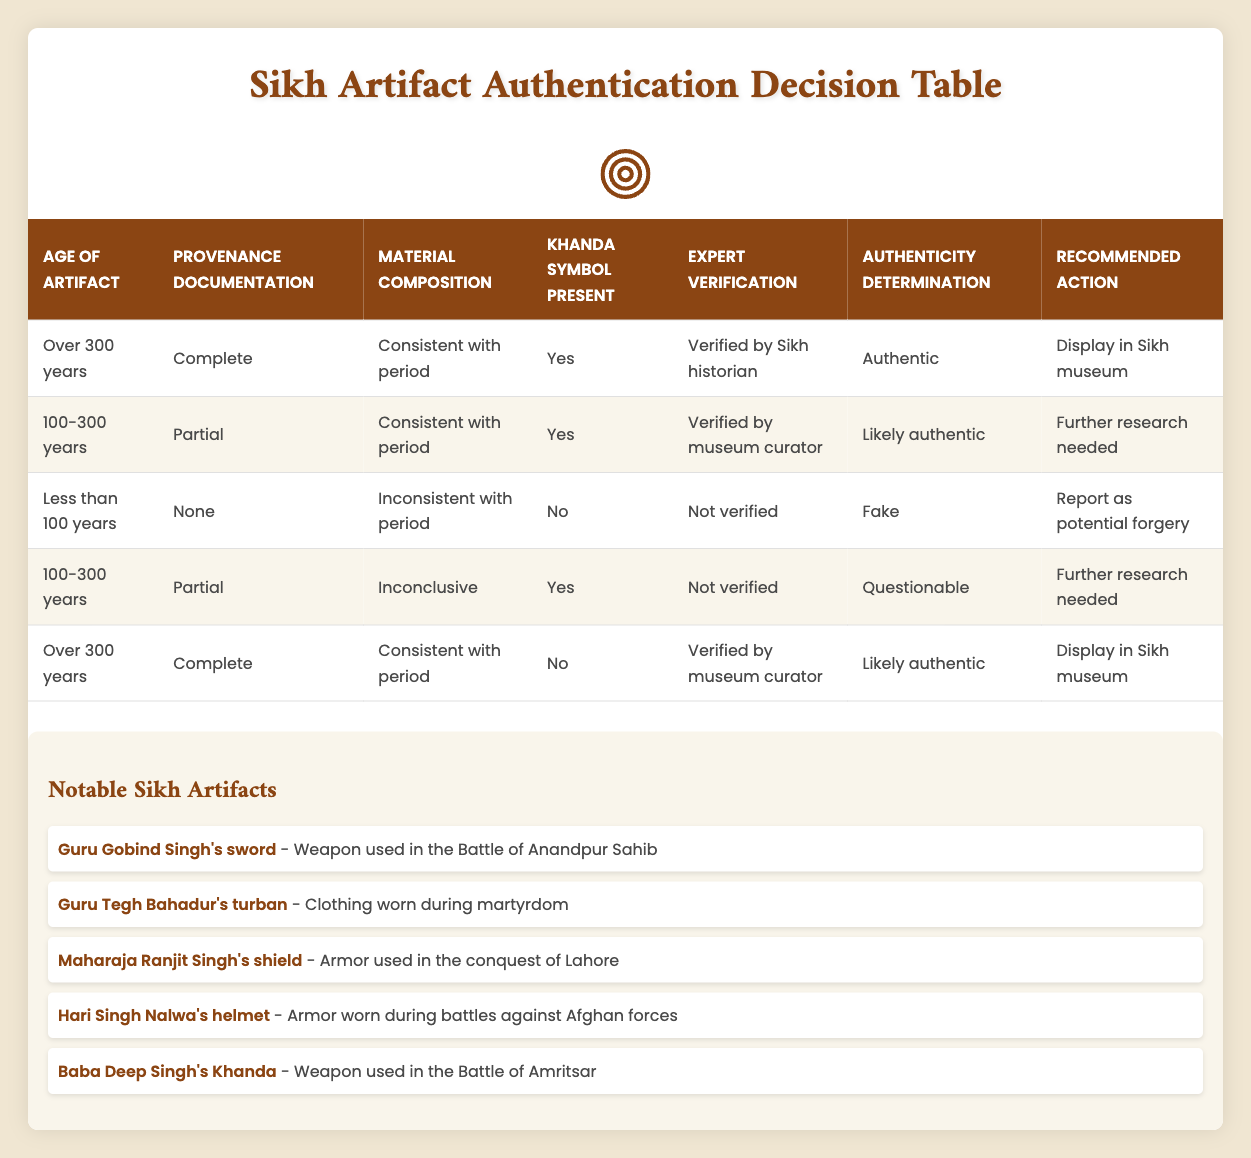What is the authenticity determination for an artifact that is over 300 years old, has complete provenance documentation, consistent material composition, the Khanda symbol present, and is verified by a Sikh historian? According to the table, the specific conditions listed match the first rule. The artifact is over 300 years old, has complete provenance documentation, consistent material composition, the Khanda symbol is present, and it is verified by a Sikh historian. Hence, it is determined to be authentic and recommended to be displayed in the Sikh museum.
Answer: Authentic How many artifacts in the table are deemed "likely authentic"? To find the number of artifacts deemed "likely authentic," we can look through the "Authenticity determination" column for this specific label. The second row and the fifth row both indicate "likely authentic," amounting to a total of 2 artifacts.
Answer: 2 Is the "Khanda symbol present" for the artifact that is less than 100 years old, has no provenance documentation, inconsistent material composition, and is not verified? The table clearly indicates that for this specific case, the specified artifact corresponds with the third rule, which states that it is fake and that the Khanda symbol is not present. Thus, the answer is no.
Answer: No What would be the recommended action for an artifact that is 100-300 years old, has partial provenance documentation, inconclusive material composition, the Khanda symbol present, and is not verified? Looking at the fourth rule, this scenario matches it exactly. It indicates that the artifact is "questionable," and therefore the recommended action is "further research needed."
Answer: Further research needed If an artifact is verified by a Sikh historian and is determined to be authentic, what is the age of that artifact? The determination of authenticity requires several conditions to be met, including age. Reviewing the rules, we see that both instances where an artifact verified by a Sikh historian is authenticated fall under the criteria of being over 300 years old or being 100-300 years old. Since there is no specification in the question, both possibilities are valid.
Answer: Over 300 years or 100-300 years What are the two different actions recommended for artifacts that are determined to be "likely authentic"? The second row represents a "likely authentic" determination, recommending "further research needed." The fifth row also indicates "likely authentic" and suggests "display in Sikh museum." Therefore, the two recommended actions for these artifacts are "further research needed" and "display in Sikh museum."
Answer: Further research needed and display in Sikh museum 